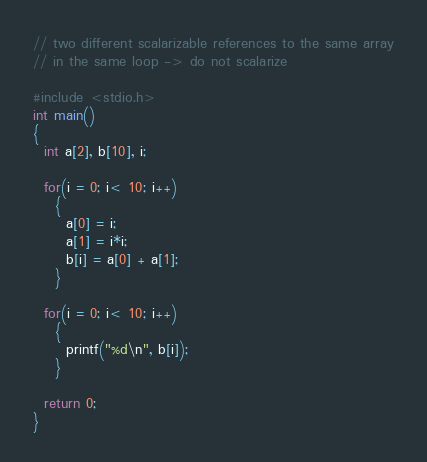<code> <loc_0><loc_0><loc_500><loc_500><_C_>// two different scalarizable references to the same array
// in the same loop -> do not scalarize

#include <stdio.h>
int main()
{
  int a[2], b[10], i;

  for(i = 0; i< 10; i++)
    {
      a[0] = i;
      a[1] = i*i;
      b[i] = a[0] + a[1];
    }

  for(i = 0; i< 10; i++)
    {
      printf("%d\n", b[i]);
    }

  return 0;
}
</code> 